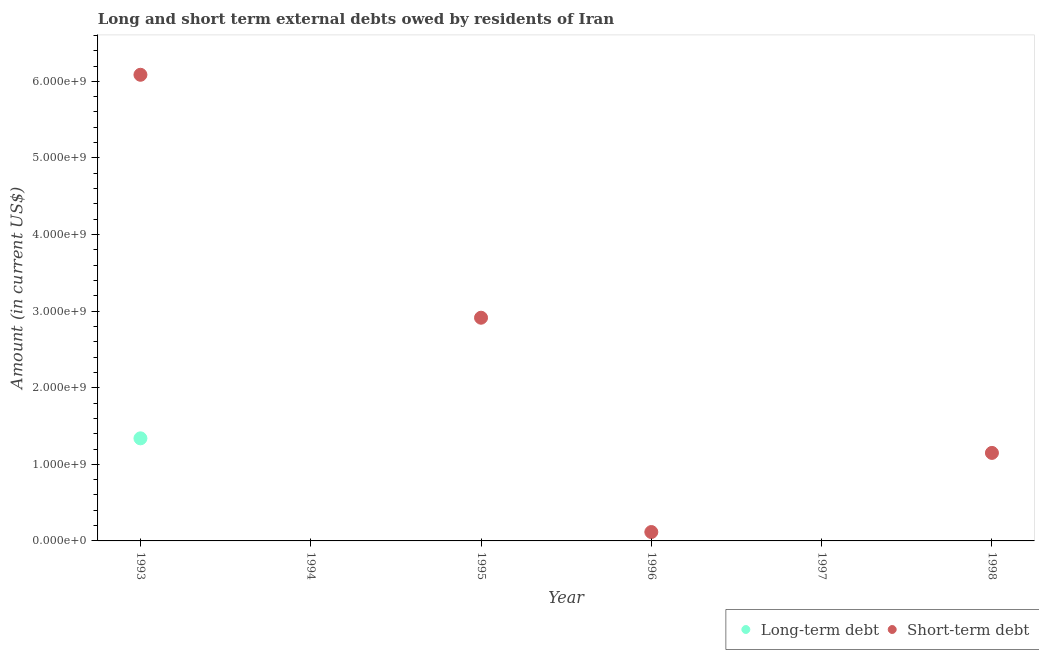How many different coloured dotlines are there?
Make the answer very short. 2. Across all years, what is the maximum long-term debts owed by residents?
Ensure brevity in your answer.  1.34e+09. Across all years, what is the minimum long-term debts owed by residents?
Give a very brief answer. 0. What is the total long-term debts owed by residents in the graph?
Offer a terse response. 1.34e+09. What is the average long-term debts owed by residents per year?
Make the answer very short. 2.23e+08. In the year 1993, what is the difference between the short-term debts owed by residents and long-term debts owed by residents?
Offer a terse response. 4.75e+09. What is the ratio of the short-term debts owed by residents in 1993 to that in 1998?
Keep it short and to the point. 5.3. What is the difference between the highest and the second highest short-term debts owed by residents?
Ensure brevity in your answer.  3.17e+09. What is the difference between the highest and the lowest long-term debts owed by residents?
Your response must be concise. 1.34e+09. Is the long-term debts owed by residents strictly greater than the short-term debts owed by residents over the years?
Your response must be concise. No. Is the long-term debts owed by residents strictly less than the short-term debts owed by residents over the years?
Your response must be concise. Yes. Does the graph contain any zero values?
Provide a short and direct response. Yes. Does the graph contain grids?
Offer a very short reply. No. Where does the legend appear in the graph?
Keep it short and to the point. Bottom right. How are the legend labels stacked?
Provide a short and direct response. Horizontal. What is the title of the graph?
Your answer should be very brief. Long and short term external debts owed by residents of Iran. What is the label or title of the X-axis?
Offer a terse response. Year. What is the label or title of the Y-axis?
Your answer should be compact. Amount (in current US$). What is the Amount (in current US$) in Long-term debt in 1993?
Provide a short and direct response. 1.34e+09. What is the Amount (in current US$) in Short-term debt in 1993?
Your response must be concise. 6.09e+09. What is the Amount (in current US$) in Long-term debt in 1995?
Keep it short and to the point. 0. What is the Amount (in current US$) in Short-term debt in 1995?
Provide a short and direct response. 2.91e+09. What is the Amount (in current US$) of Long-term debt in 1996?
Offer a terse response. 0. What is the Amount (in current US$) in Short-term debt in 1996?
Offer a terse response. 1.16e+08. What is the Amount (in current US$) in Long-term debt in 1997?
Provide a short and direct response. 0. What is the Amount (in current US$) in Long-term debt in 1998?
Offer a very short reply. 0. What is the Amount (in current US$) in Short-term debt in 1998?
Make the answer very short. 1.15e+09. Across all years, what is the maximum Amount (in current US$) of Long-term debt?
Your response must be concise. 1.34e+09. Across all years, what is the maximum Amount (in current US$) of Short-term debt?
Make the answer very short. 6.09e+09. What is the total Amount (in current US$) in Long-term debt in the graph?
Keep it short and to the point. 1.34e+09. What is the total Amount (in current US$) in Short-term debt in the graph?
Give a very brief answer. 1.03e+1. What is the difference between the Amount (in current US$) of Short-term debt in 1993 and that in 1995?
Your response must be concise. 3.17e+09. What is the difference between the Amount (in current US$) of Short-term debt in 1993 and that in 1996?
Make the answer very short. 5.97e+09. What is the difference between the Amount (in current US$) of Short-term debt in 1993 and that in 1998?
Your answer should be compact. 4.94e+09. What is the difference between the Amount (in current US$) of Short-term debt in 1995 and that in 1996?
Keep it short and to the point. 2.80e+09. What is the difference between the Amount (in current US$) in Short-term debt in 1995 and that in 1998?
Offer a very short reply. 1.76e+09. What is the difference between the Amount (in current US$) of Short-term debt in 1996 and that in 1998?
Your response must be concise. -1.03e+09. What is the difference between the Amount (in current US$) in Long-term debt in 1993 and the Amount (in current US$) in Short-term debt in 1995?
Your response must be concise. -1.57e+09. What is the difference between the Amount (in current US$) in Long-term debt in 1993 and the Amount (in current US$) in Short-term debt in 1996?
Give a very brief answer. 1.22e+09. What is the difference between the Amount (in current US$) of Long-term debt in 1993 and the Amount (in current US$) of Short-term debt in 1998?
Make the answer very short. 1.90e+08. What is the average Amount (in current US$) in Long-term debt per year?
Your answer should be very brief. 2.23e+08. What is the average Amount (in current US$) of Short-term debt per year?
Keep it short and to the point. 1.71e+09. In the year 1993, what is the difference between the Amount (in current US$) in Long-term debt and Amount (in current US$) in Short-term debt?
Provide a short and direct response. -4.75e+09. What is the ratio of the Amount (in current US$) of Short-term debt in 1993 to that in 1995?
Your response must be concise. 2.09. What is the ratio of the Amount (in current US$) of Short-term debt in 1993 to that in 1996?
Keep it short and to the point. 52.47. What is the ratio of the Amount (in current US$) in Short-term debt in 1993 to that in 1998?
Give a very brief answer. 5.3. What is the ratio of the Amount (in current US$) in Short-term debt in 1995 to that in 1996?
Provide a short and direct response. 25.12. What is the ratio of the Amount (in current US$) of Short-term debt in 1995 to that in 1998?
Your answer should be compact. 2.54. What is the ratio of the Amount (in current US$) of Short-term debt in 1996 to that in 1998?
Offer a terse response. 0.1. What is the difference between the highest and the second highest Amount (in current US$) in Short-term debt?
Make the answer very short. 3.17e+09. What is the difference between the highest and the lowest Amount (in current US$) of Long-term debt?
Ensure brevity in your answer.  1.34e+09. What is the difference between the highest and the lowest Amount (in current US$) of Short-term debt?
Provide a short and direct response. 6.09e+09. 